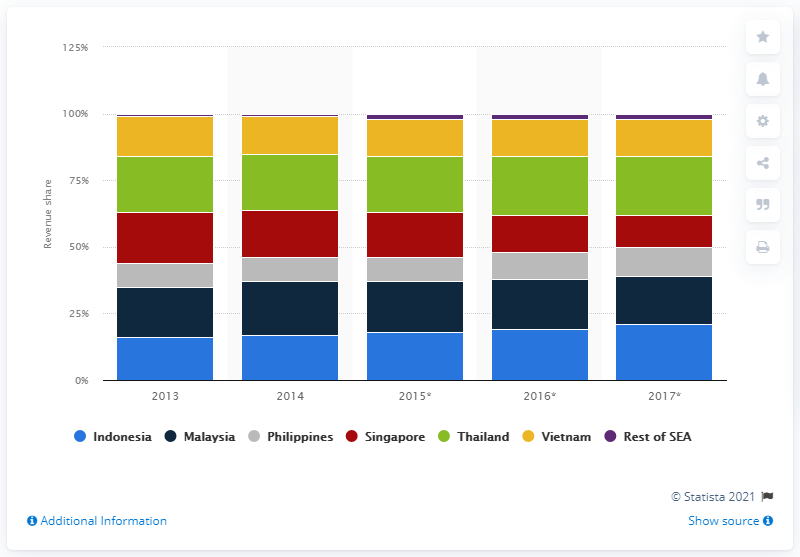List a handful of essential elements in this visual. In 2016, Indonesia was the largest mobile gaming market in Southeast Asia. 